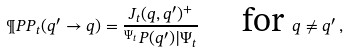<formula> <loc_0><loc_0><loc_500><loc_500>\P P P _ { t } ( q ^ { \prime } \to q ) = \frac { J _ { t } ( q , q ^ { \prime } ) ^ { + } } { ^ { \Psi _ { t } } { P ( q ^ { \prime } ) | \Psi _ { t } } } \quad \text { for } q \neq q ^ { \prime } \, ,</formula> 